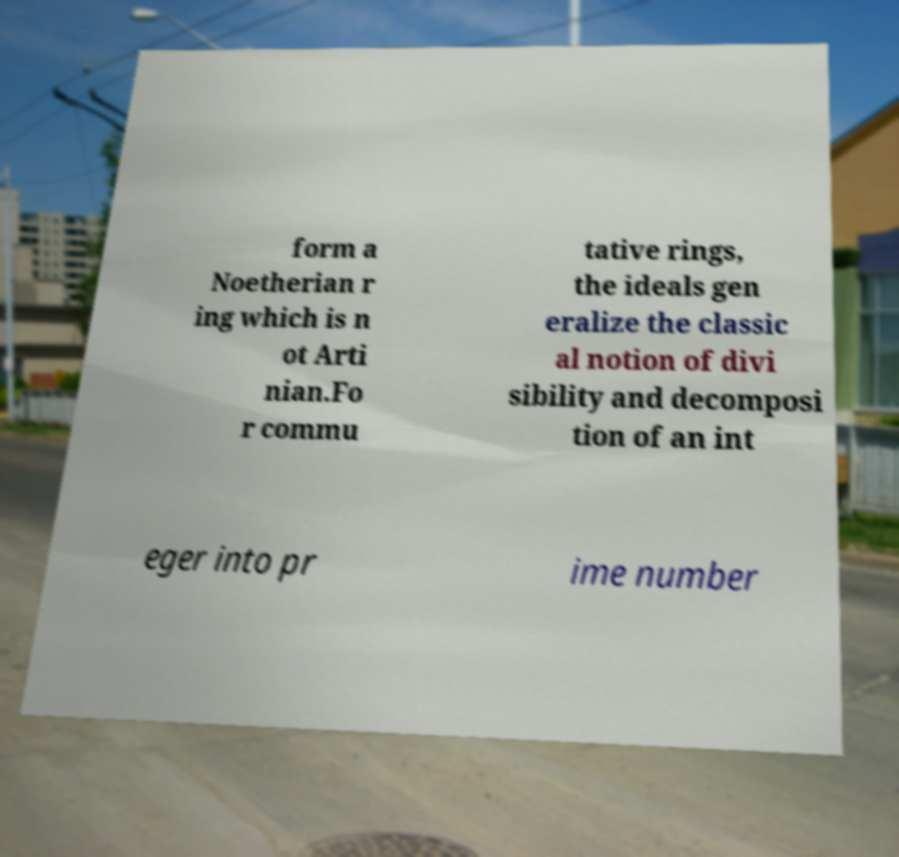Please read and relay the text visible in this image. What does it say? form a Noetherian r ing which is n ot Arti nian.Fo r commu tative rings, the ideals gen eralize the classic al notion of divi sibility and decomposi tion of an int eger into pr ime number 